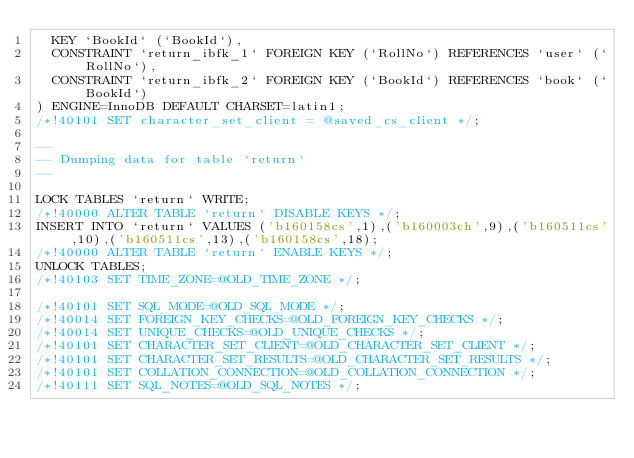<code> <loc_0><loc_0><loc_500><loc_500><_SQL_>  KEY `BookId` (`BookId`),
  CONSTRAINT `return_ibfk_1` FOREIGN KEY (`RollNo`) REFERENCES `user` (`RollNo`),
  CONSTRAINT `return_ibfk_2` FOREIGN KEY (`BookId`) REFERENCES `book` (`BookId`)
) ENGINE=InnoDB DEFAULT CHARSET=latin1;
/*!40101 SET character_set_client = @saved_cs_client */;

--
-- Dumping data for table `return`
--

LOCK TABLES `return` WRITE;
/*!40000 ALTER TABLE `return` DISABLE KEYS */;
INSERT INTO `return` VALUES ('b160158cs',1),('b160003ch',9),('b160511cs',10),('b160511cs',13),('b160158cs',18);
/*!40000 ALTER TABLE `return` ENABLE KEYS */;
UNLOCK TABLES;
/*!40103 SET TIME_ZONE=@OLD_TIME_ZONE */;

/*!40101 SET SQL_MODE=@OLD_SQL_MODE */;
/*!40014 SET FOREIGN_KEY_CHECKS=@OLD_FOREIGN_KEY_CHECKS */;
/*!40014 SET UNIQUE_CHECKS=@OLD_UNIQUE_CHECKS */;
/*!40101 SET CHARACTER_SET_CLIENT=@OLD_CHARACTER_SET_CLIENT */;
/*!40101 SET CHARACTER_SET_RESULTS=@OLD_CHARACTER_SET_RESULTS */;
/*!40101 SET COLLATION_CONNECTION=@OLD_COLLATION_CONNECTION */;
/*!40111 SET SQL_NOTES=@OLD_SQL_NOTES */;
</code> 